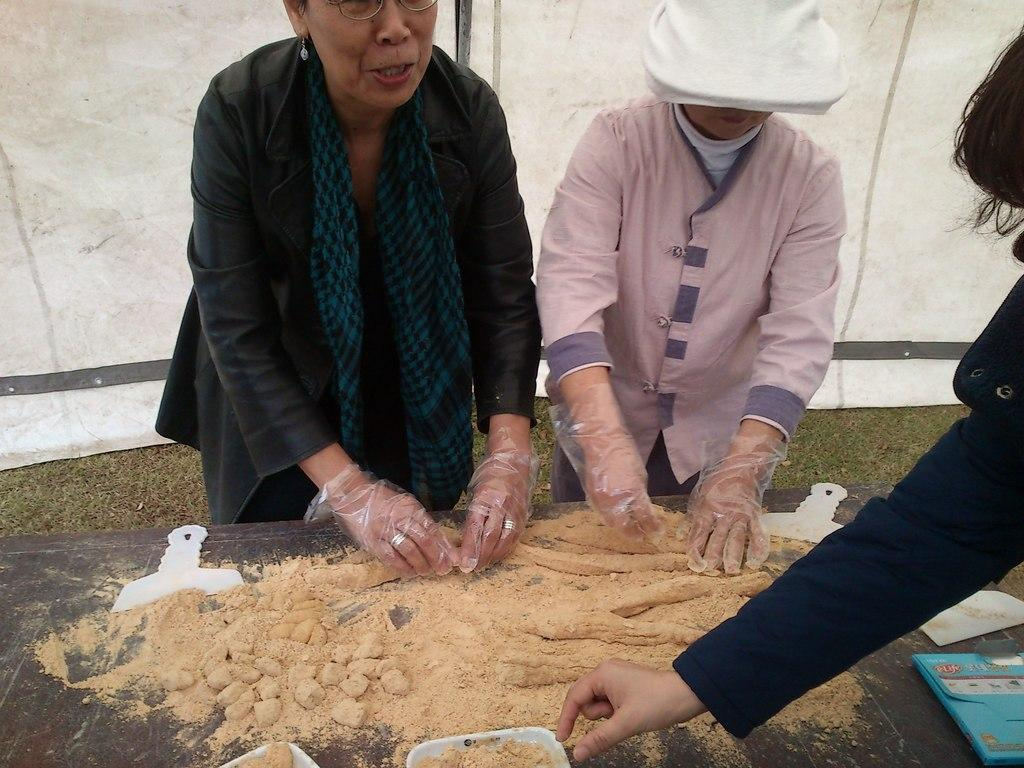How many people are present in the image? There are three people in the image. What are the people wearing on their hands? The people are wearing gloves. What activity are the people engaged in? The people are preparing a dough. What additional element can be seen in the image? There is a banner visible in the image. What type of sail can be seen in the image? There is no sail present in the image. What type of business are the people running in the image? The image does not provide information about a business; it shows people preparing a dough. 